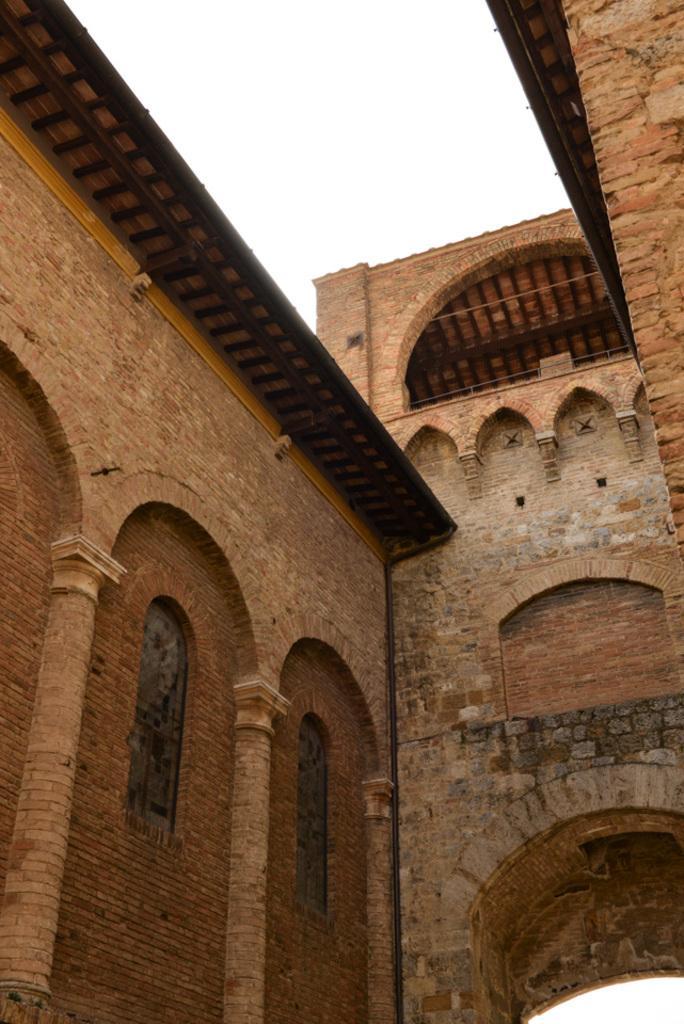Describe this image in one or two sentences. In the image we can see there is a building and it is made up of red bricks. 